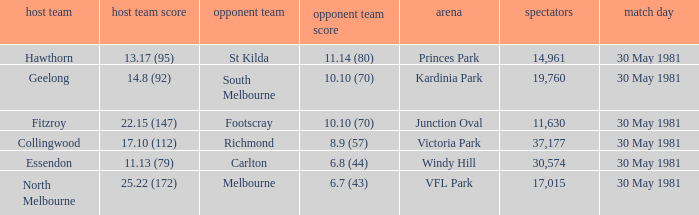What team played away at vfl park? Melbourne. 